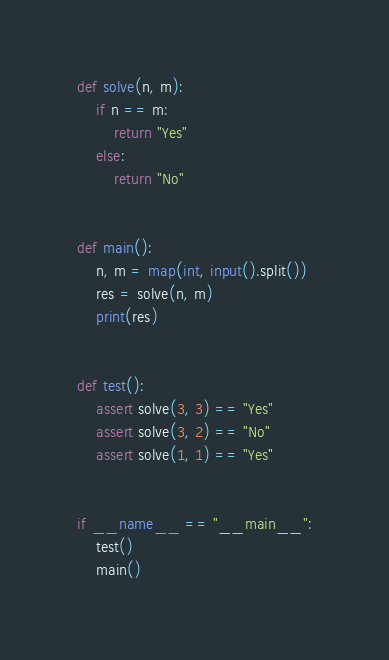Convert code to text. <code><loc_0><loc_0><loc_500><loc_500><_Python_>def solve(n, m):
    if n == m:
        return "Yes"
    else:
        return "No"


def main():
    n, m = map(int, input().split())
    res = solve(n, m)
    print(res)


def test():
    assert solve(3, 3) == "Yes"
    assert solve(3, 2) == "No"
    assert solve(1, 1) == "Yes"


if __name__ == "__main__":
    test()
    main()
</code> 